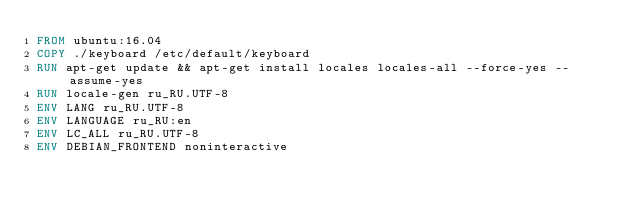Convert code to text. <code><loc_0><loc_0><loc_500><loc_500><_Dockerfile_>FROM ubuntu:16.04
COPY ./keyboard /etc/default/keyboard
RUN apt-get update && apt-get install locales locales-all --force-yes --assume-yes
RUN locale-gen ru_RU.UTF-8
ENV LANG ru_RU.UTF-8
ENV LANGUAGE ru_RU:en
ENV LC_ALL ru_RU.UTF-8
ENV DEBIAN_FRONTEND noninteractive</code> 